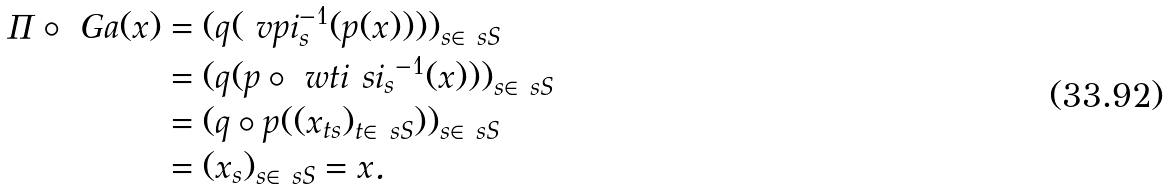<formula> <loc_0><loc_0><loc_500><loc_500>\Pi \circ \ G a ( x ) & = ( q ( \ v p i _ { s } ^ { - 1 } ( p ( x ) ) ) ) _ { s \in \ s S } \\ & = ( q ( p \circ \ w t i { \ s i _ { s } } ^ { - 1 } ( x ) ) ) _ { s \in \ s S } \\ & = ( q \circ p ( ( x _ { t s } ) _ { t \in \ s S } ) ) _ { s \in \ s S } \\ & = ( x _ { s } ) _ { s \in \ s S } = x .</formula> 